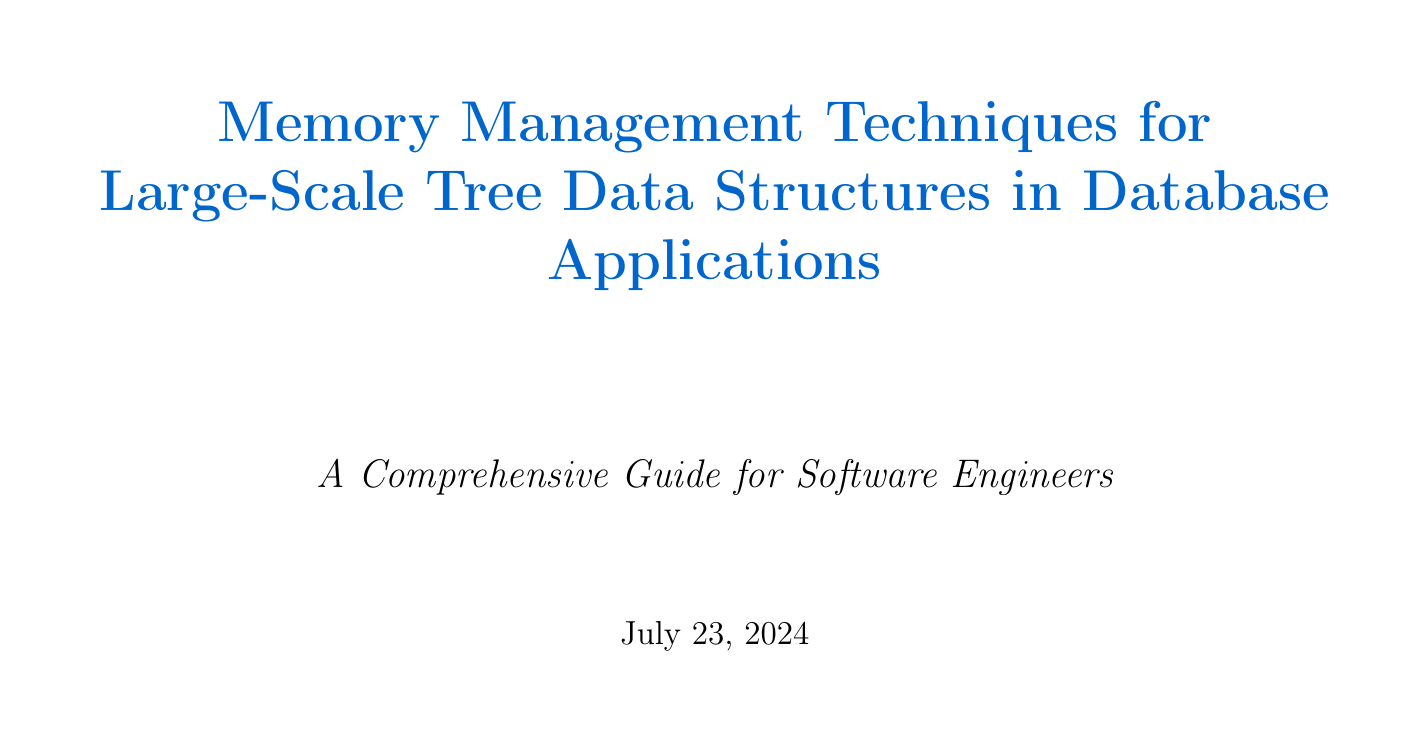What is the main focus of the manual? The manual focuses on techniques for effective memory management in large-scale tree data structures for databases.
Answer: memory management techniques What optimization technique is mentioned for B-tree node sizes? The manual suggests modifying the FILLFACTOR parameter in PostgreSQL to control the packing of B-tree pages.
Answer: FILLFACTOR Which database employs memory-mapped files for large trees? The manual states that MongoDB utilizes memory-mapped files to efficiently handle large tree structures.
Answer: MongoDB What is one benefit of lazy loading in database applications? Lazy loading helps reduce memory usage by loading only the required portions of the tree on demand.
Answer: reduce memory usage Name one memory profiling tool mentioned. The manual lists VisualVM as a memory profiling tool used to identify memory leaks.
Answer: VisualVM What are two solutions suggested for garbage collection optimization? The manual suggests generational garbage collection tuning and off-heap memory solutions.
Answer: generational GC tuning, off-heap memory Which distributed technology is mentioned for managing tree structures? The manual refers to Apache Ignite as a technology for implementing distributed tree structures.
Answer: Apache Ignite What compression technique is effective for string-based keys? The manual indicates that prefix compression is effective for string-based keys in B-tree indexes.
Answer: prefix compression 